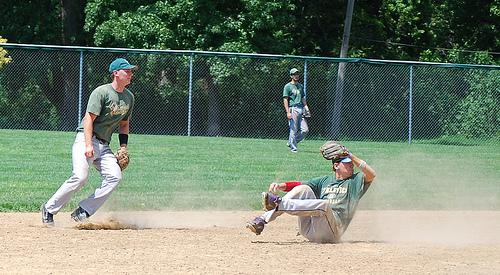Question: what is this game?
Choices:
A. Football.
B. Baseball.
C. Hockey.
D. Basketball.
Answer with the letter. Answer: B Question: how many players can we see?
Choices:
A. Two.
B. Three.
C. Four.
D. Five.
Answer with the letter. Answer: B Question: what is the seated player holding over his head?
Choices:
A. His mitt.
B. His glove.
C. His beer.
D. His hat.
Answer with the letter. Answer: A Question: why is there a cloud of dust?
Choices:
A. A player just slid.
B. The umpire tripped.
C. The ball hit the ground.
D. The players kicked it up by moving fast.
Answer with the letter. Answer: D Question: what color are the players shirts?
Choices:
A. Red.
B. Green.
C. Blue.
D. Brown.
Answer with the letter. Answer: B 